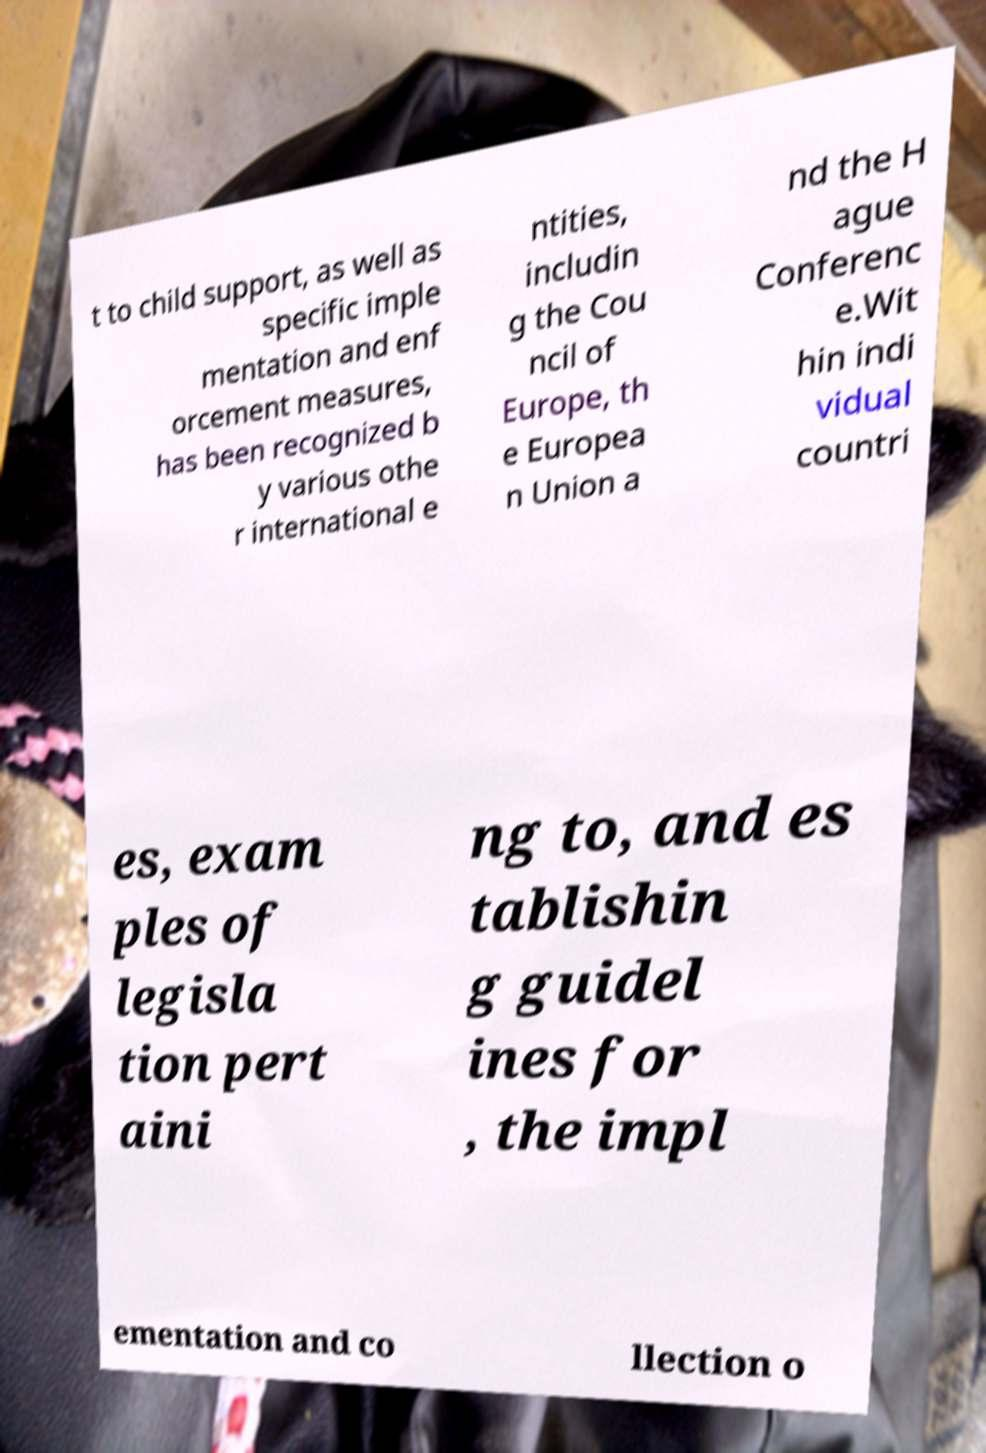Can you read and provide the text displayed in the image?This photo seems to have some interesting text. Can you extract and type it out for me? t to child support, as well as specific imple mentation and enf orcement measures, has been recognized b y various othe r international e ntities, includin g the Cou ncil of Europe, th e Europea n Union a nd the H ague Conferenc e.Wit hin indi vidual countri es, exam ples of legisla tion pert aini ng to, and es tablishin g guidel ines for , the impl ementation and co llection o 